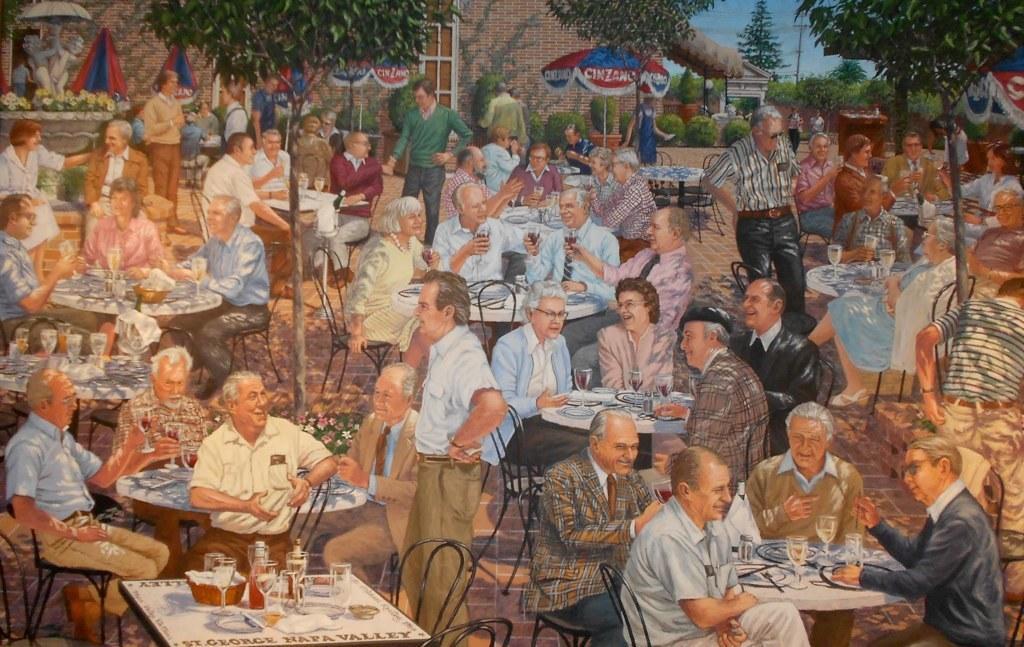Describe this image in one or two sentences. In this image I can see a painting of people sitting on chairs and also I can see number of tables, glasses, trees and a building. 